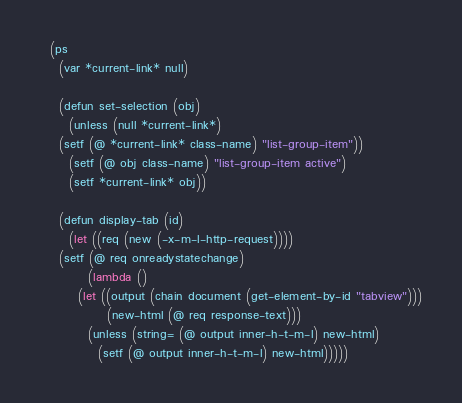<code> <loc_0><loc_0><loc_500><loc_500><_Lisp_>  (ps
    (var *current-link* null)

    (defun set-selection (obj)
      (unless (null *current-link*)
	(setf (@ *current-link* class-name) "list-group-item"))
      (setf (@ obj class-name) "list-group-item active")
      (setf *current-link* obj))

    (defun display-tab (id)
      (let ((req (new (-x-m-l-http-request))))
	(setf (@ req onreadystatechange)
	      (lambda ()
		(let ((output (chain document (get-element-by-id "tabview")))
		      (new-html (@ req response-text)))
		  (unless (string= (@ output inner-h-t-m-l) new-html)
		    (setf (@ output inner-h-t-m-l) new-html)))))</code> 